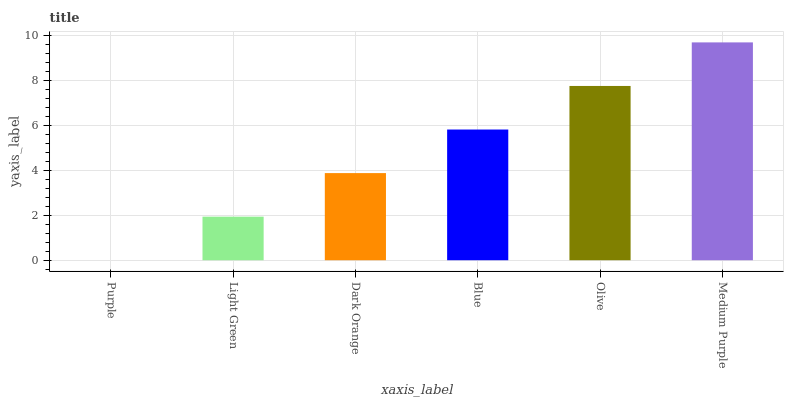Is Purple the minimum?
Answer yes or no. Yes. Is Medium Purple the maximum?
Answer yes or no. Yes. Is Light Green the minimum?
Answer yes or no. No. Is Light Green the maximum?
Answer yes or no. No. Is Light Green greater than Purple?
Answer yes or no. Yes. Is Purple less than Light Green?
Answer yes or no. Yes. Is Purple greater than Light Green?
Answer yes or no. No. Is Light Green less than Purple?
Answer yes or no. No. Is Blue the high median?
Answer yes or no. Yes. Is Dark Orange the low median?
Answer yes or no. Yes. Is Purple the high median?
Answer yes or no. No. Is Blue the low median?
Answer yes or no. No. 